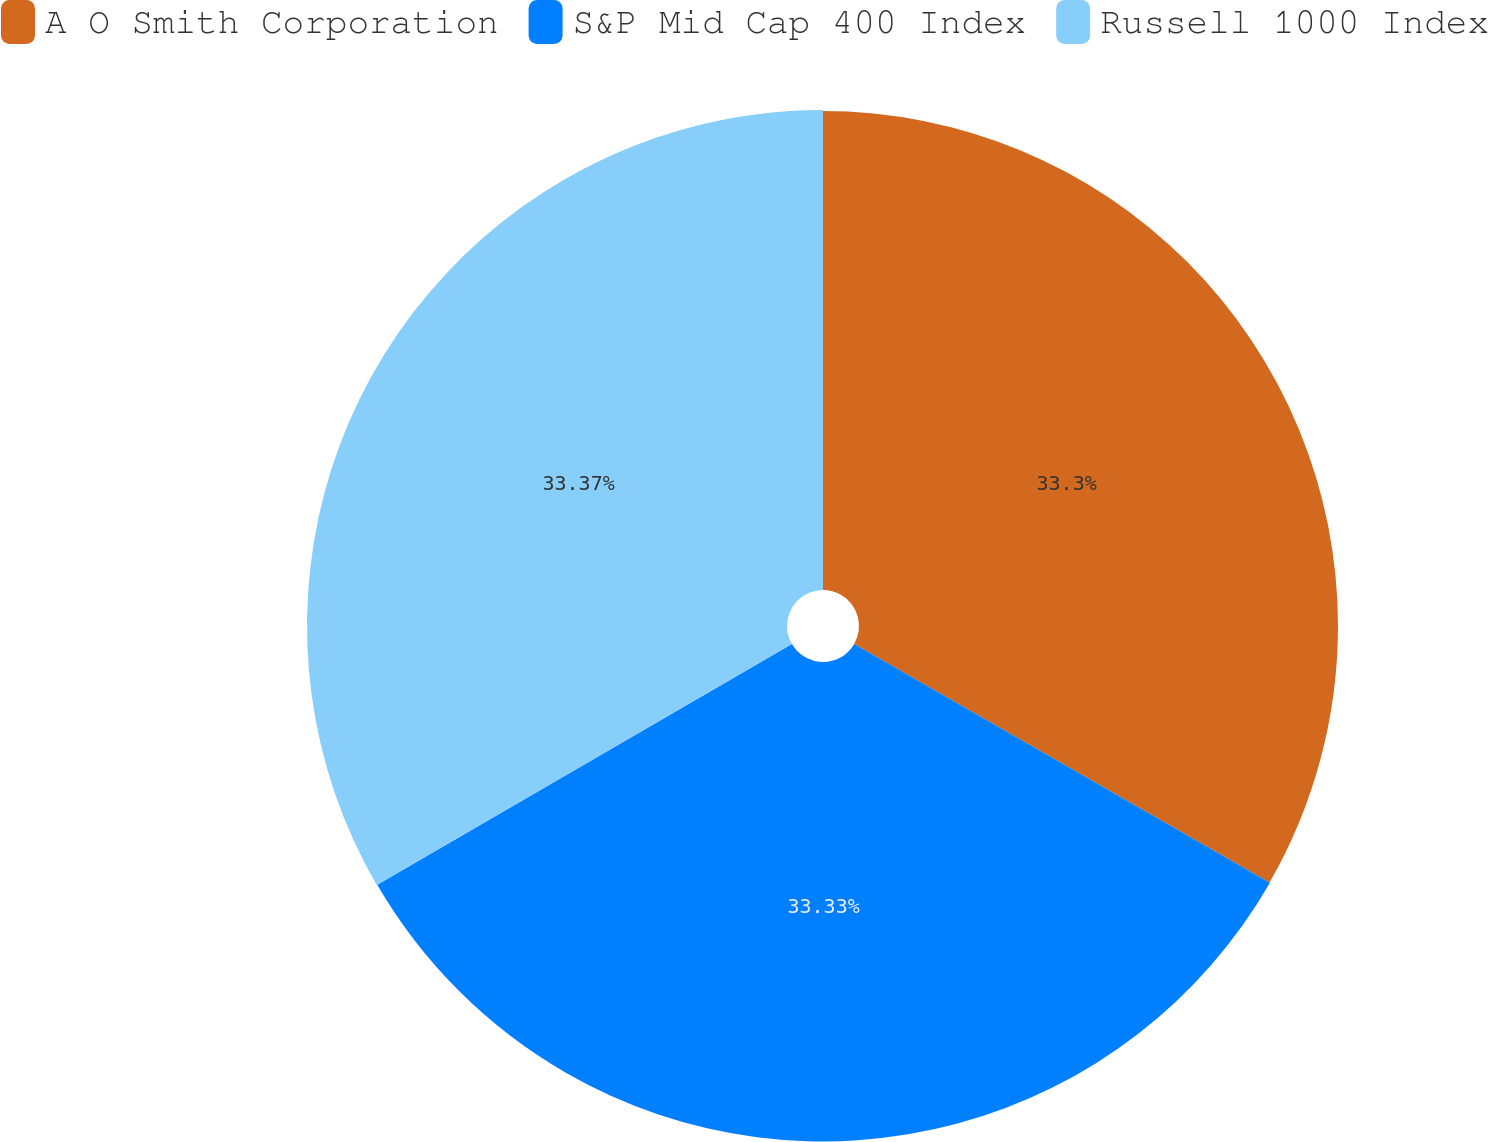Convert chart. <chart><loc_0><loc_0><loc_500><loc_500><pie_chart><fcel>A O Smith Corporation<fcel>S&P Mid Cap 400 Index<fcel>Russell 1000 Index<nl><fcel>33.3%<fcel>33.33%<fcel>33.37%<nl></chart> 